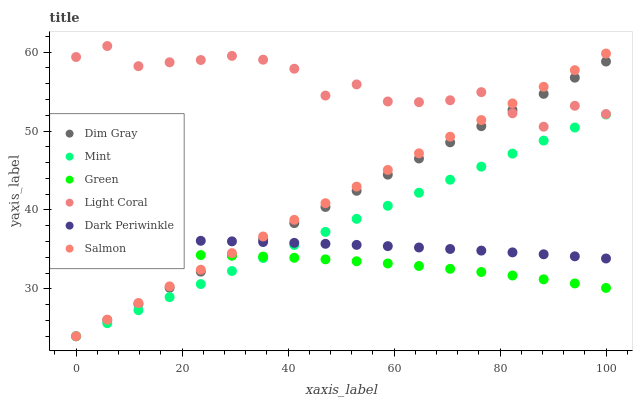Does Green have the minimum area under the curve?
Answer yes or no. Yes. Does Light Coral have the maximum area under the curve?
Answer yes or no. Yes. Does Salmon have the minimum area under the curve?
Answer yes or no. No. Does Salmon have the maximum area under the curve?
Answer yes or no. No. Is Salmon the smoothest?
Answer yes or no. Yes. Is Light Coral the roughest?
Answer yes or no. Yes. Is Light Coral the smoothest?
Answer yes or no. No. Is Salmon the roughest?
Answer yes or no. No. Does Dim Gray have the lowest value?
Answer yes or no. Yes. Does Light Coral have the lowest value?
Answer yes or no. No. Does Light Coral have the highest value?
Answer yes or no. Yes. Does Salmon have the highest value?
Answer yes or no. No. Is Green less than Dark Periwinkle?
Answer yes or no. Yes. Is Light Coral greater than Mint?
Answer yes or no. Yes. Does Dim Gray intersect Light Coral?
Answer yes or no. Yes. Is Dim Gray less than Light Coral?
Answer yes or no. No. Is Dim Gray greater than Light Coral?
Answer yes or no. No. Does Green intersect Dark Periwinkle?
Answer yes or no. No. 